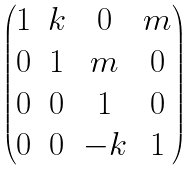<formula> <loc_0><loc_0><loc_500><loc_500>\begin{pmatrix} 1 & k & 0 & m \\ 0 & 1 & m & 0 \\ 0 & 0 & 1 & 0 \\ 0 & 0 & - k & 1 \end{pmatrix}</formula> 